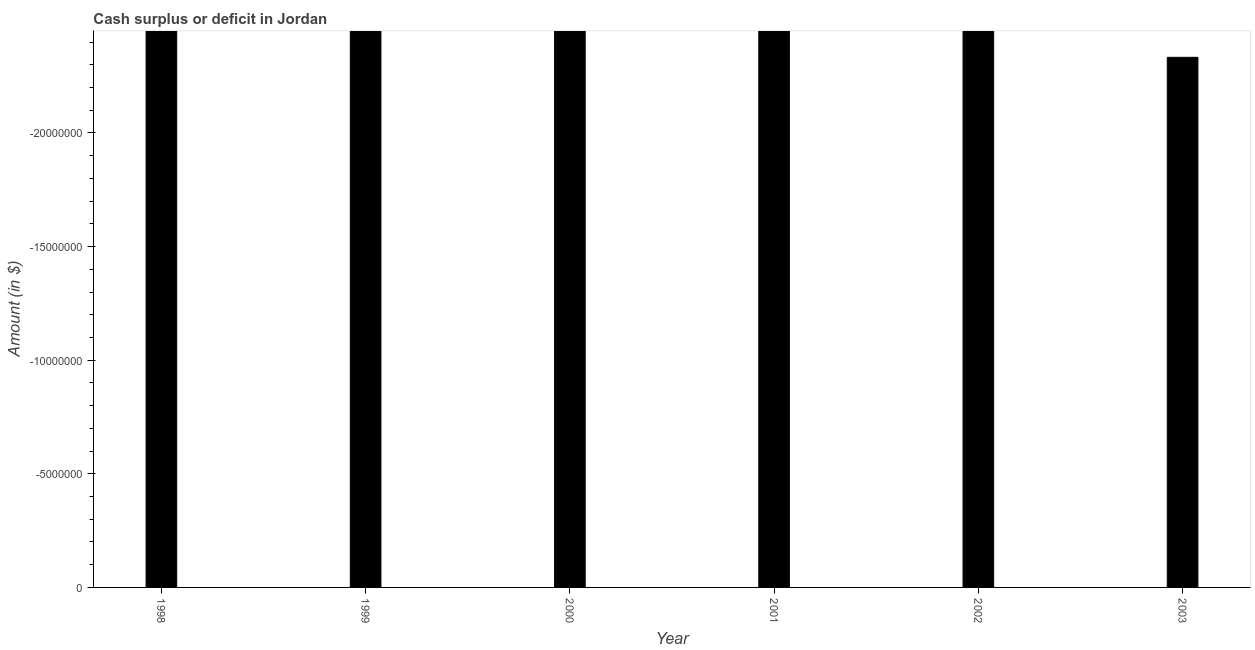Does the graph contain grids?
Your answer should be compact. No. What is the title of the graph?
Offer a terse response. Cash surplus or deficit in Jordan. What is the label or title of the Y-axis?
Your response must be concise. Amount (in $). What is the cash surplus or deficit in 2000?
Make the answer very short. 0. What is the sum of the cash surplus or deficit?
Ensure brevity in your answer.  0. What is the average cash surplus or deficit per year?
Keep it short and to the point. 0. In how many years, is the cash surplus or deficit greater than the average cash surplus or deficit taken over all years?
Provide a succinct answer. 0. Are all the bars in the graph horizontal?
Give a very brief answer. No. How many years are there in the graph?
Your answer should be compact. 6. Are the values on the major ticks of Y-axis written in scientific E-notation?
Your answer should be very brief. No. What is the Amount (in $) of 1999?
Your response must be concise. 0. What is the Amount (in $) of 2000?
Offer a terse response. 0. What is the Amount (in $) in 2003?
Give a very brief answer. 0. 